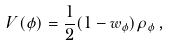Convert formula to latex. <formula><loc_0><loc_0><loc_500><loc_500>V ( \phi ) = \frac { 1 } { 2 } ( 1 - w _ { \phi } ) \rho _ { \phi } \, ,</formula> 